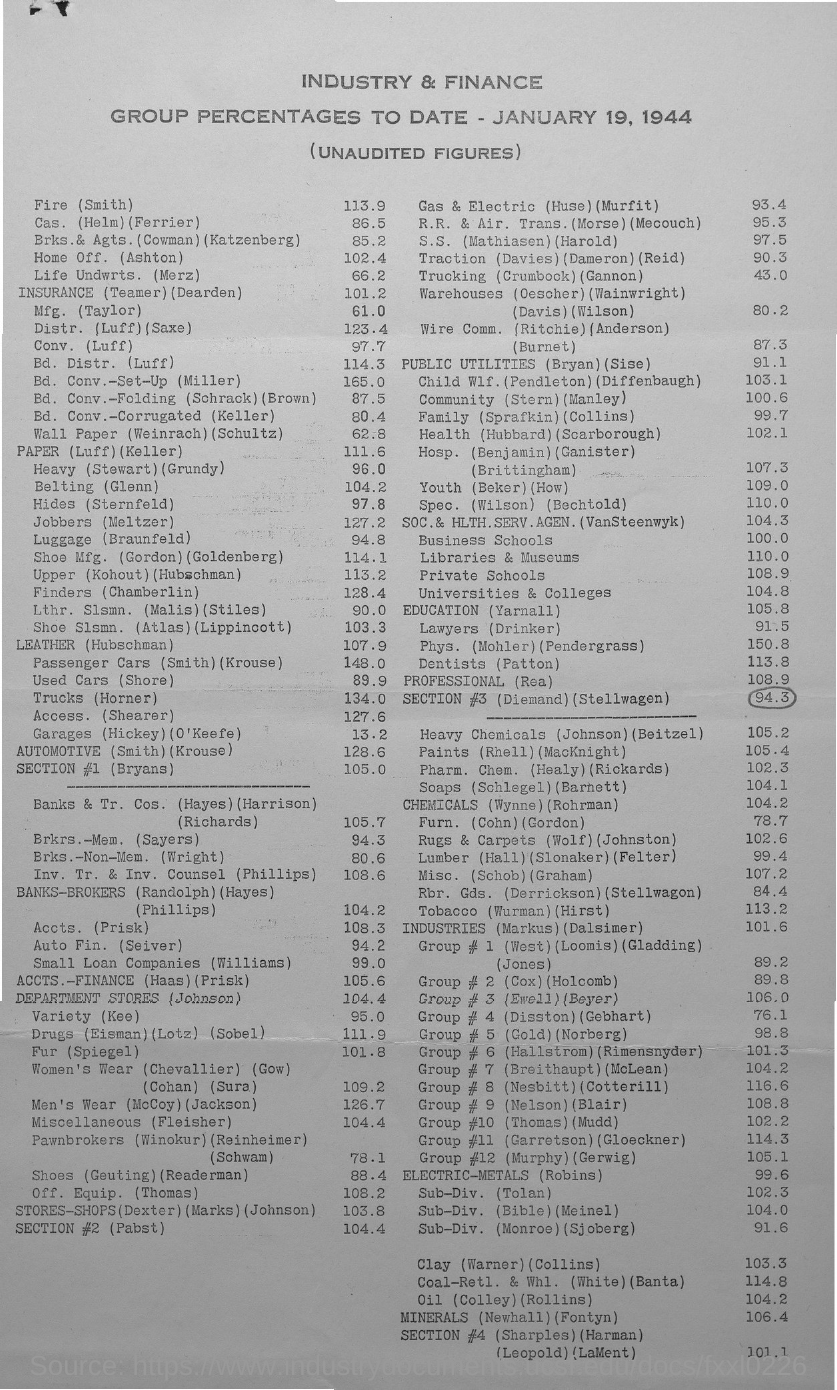Point out several critical features in this image. The group percentage of Luggage (Braunfeld) is 94.8%. The date mentioned in the document is January 19, 1944. The group percentage for Fire (Smith) is 113.9. The group percentage of Trucks (Horner) is 134.0%. This means that the percentage of trucks in the Horner group is higher than 100% and it exceeds the total percentage of trucks in all groups combined. 